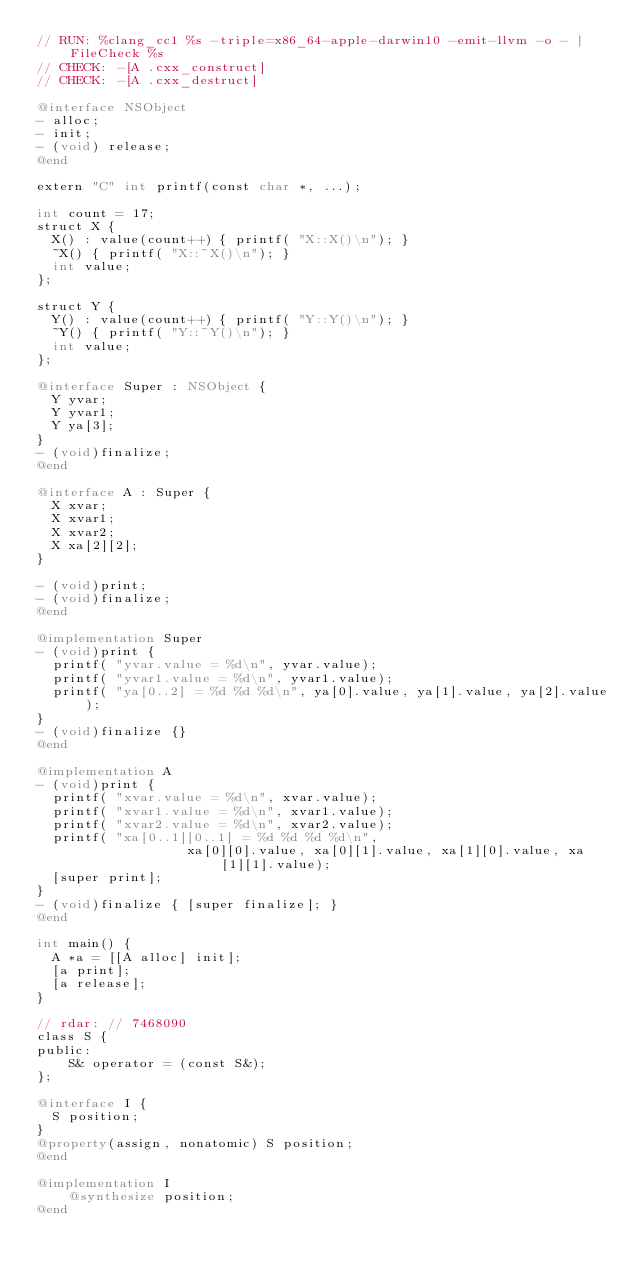Convert code to text. <code><loc_0><loc_0><loc_500><loc_500><_ObjectiveC_>// RUN: %clang_cc1 %s -triple=x86_64-apple-darwin10 -emit-llvm -o - | FileCheck %s
// CHECK: -[A .cxx_construct]
// CHECK: -[A .cxx_destruct]

@interface NSObject 
- alloc;
- init;
- (void) release;
@end

extern "C" int printf(const char *, ...);

int count = 17;
struct X {
  X() : value(count++) { printf( "X::X()\n"); }
  ~X() { printf( "X::~X()\n"); }
  int value;
};

struct Y {
  Y() : value(count++) { printf( "Y::Y()\n"); }
  ~Y() { printf( "Y::~Y()\n"); }
  int value;
};

@interface Super : NSObject {
  Y yvar;
  Y yvar1;
  Y ya[3];
}
- (void)finalize;
@end

@interface A : Super {
  X xvar;
  X xvar1;
  X xvar2;
  X xa[2][2];
}

- (void)print;
- (void)finalize;
@end

@implementation Super
- (void)print {
  printf( "yvar.value = %d\n", yvar.value);
  printf( "yvar1.value = %d\n", yvar1.value);
  printf( "ya[0..2] = %d %d %d\n", ya[0].value, ya[1].value, ya[2].value);
}
- (void)finalize {}
@end

@implementation A
- (void)print {
  printf( "xvar.value = %d\n", xvar.value);
  printf( "xvar1.value = %d\n", xvar1.value);
  printf( "xvar2.value = %d\n", xvar2.value);
  printf( "xa[0..1][0..1] = %d %d %d %d\n",
                   xa[0][0].value, xa[0][1].value, xa[1][0].value, xa[1][1].value);
  [super print];
}
- (void)finalize { [super finalize]; }
@end

int main() {
  A *a = [[A alloc] init];
  [a print];
  [a release];
}

// rdar: // 7468090
class S {
public:
	S& operator = (const S&);
};

@interface I {
  S position;
}
@property(assign, nonatomic) S position;
@end

@implementation I
	@synthesize position;
@end
</code> 